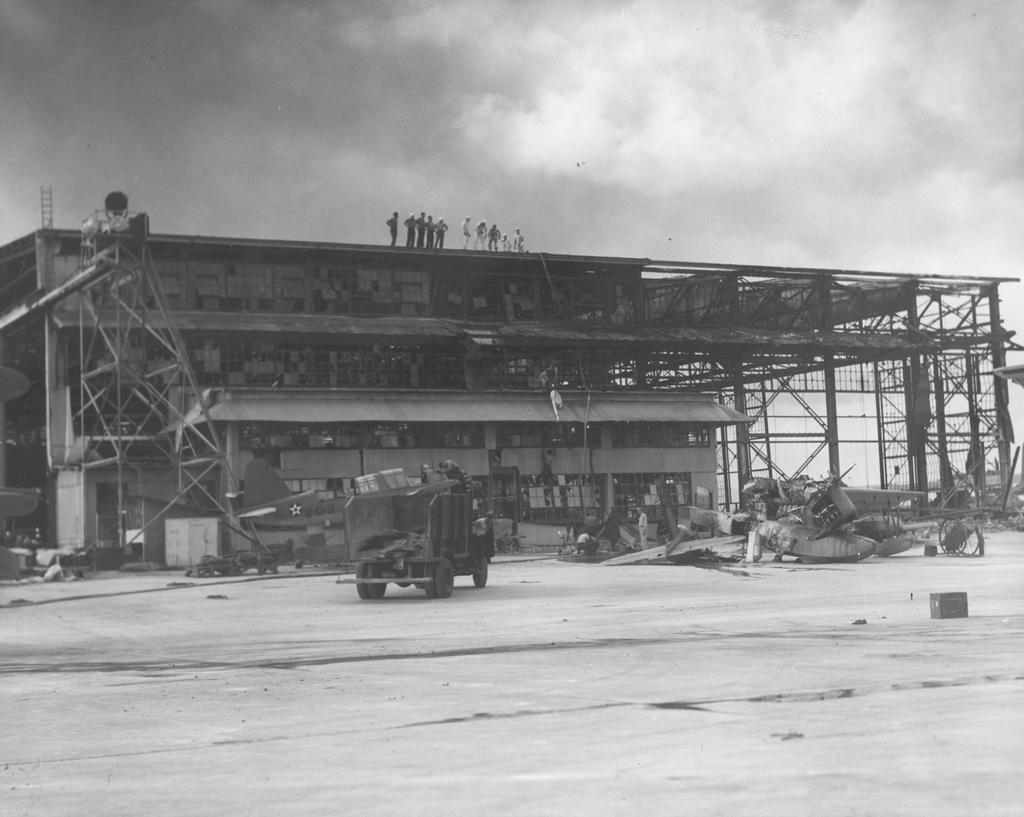How many people are in the image? There is a group of people in the image. What are some people doing in the image? Some people are standing on a building. What can be seen in front of the building? There are metal rods and a vehicle in front of the building. Are there any other people in the image besides those on the building? Yes, there are more people in front of the building. What type of chin can be seen on the snakes in the image? There are no snakes or chins present in the image. What is the scene depicted in the image? The image shows a group of people, some standing on a building, and others in front of the building, along with metal rods and a vehicle. 